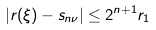<formula> <loc_0><loc_0><loc_500><loc_500>| r ( \xi ) - s _ { n \nu } | \leq 2 ^ { n + 1 } r _ { 1 }</formula> 